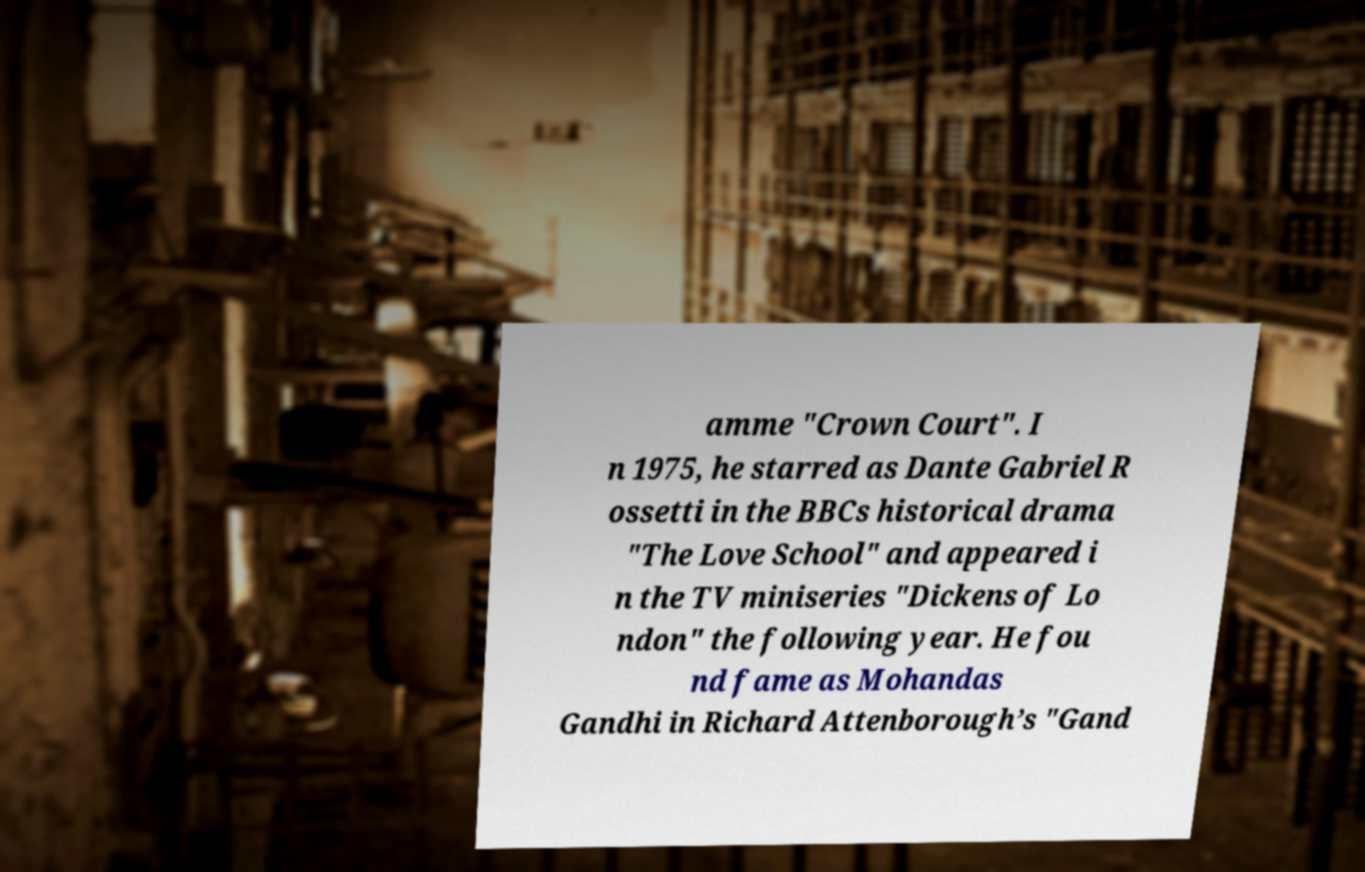Can you read and provide the text displayed in the image?This photo seems to have some interesting text. Can you extract and type it out for me? amme "Crown Court". I n 1975, he starred as Dante Gabriel R ossetti in the BBCs historical drama "The Love School" and appeared i n the TV miniseries "Dickens of Lo ndon" the following year. He fou nd fame as Mohandas Gandhi in Richard Attenborough’s "Gand 